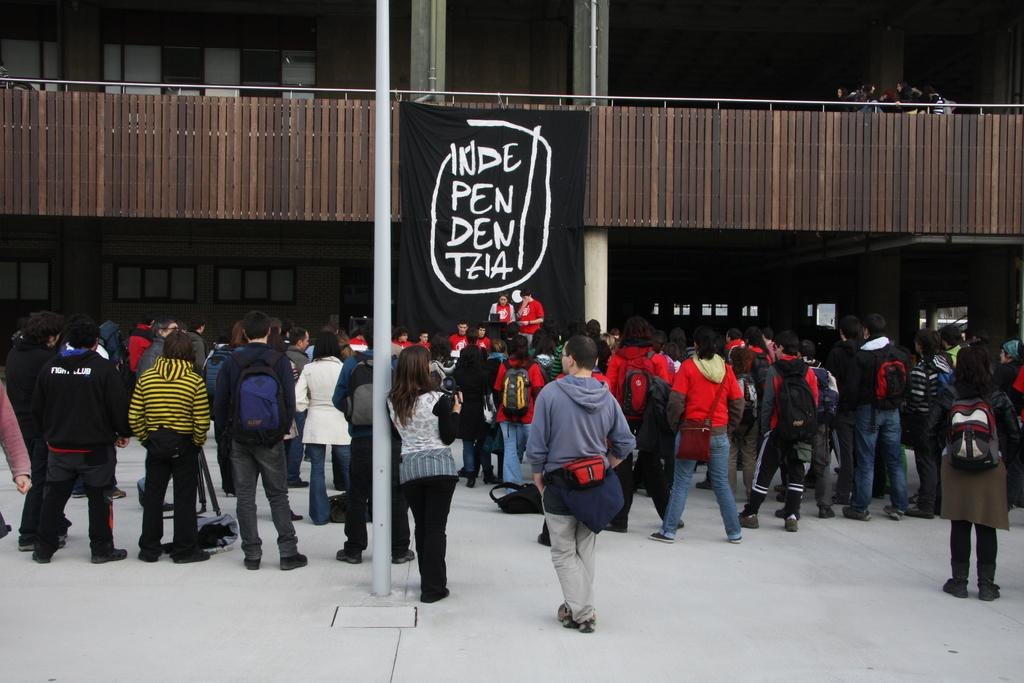What can be seen in the image? There are people standing in the image. What is in the middle of the image? There is a black cloth with text in the middle of the image. What type of material is the railing made of? The wooden railing is visible in the image. How many legs can be seen on the people in the image? The question cannot be answered definitively from the provided facts, as the number of legs visible would depend on the angle and positioning of the people in the image. 